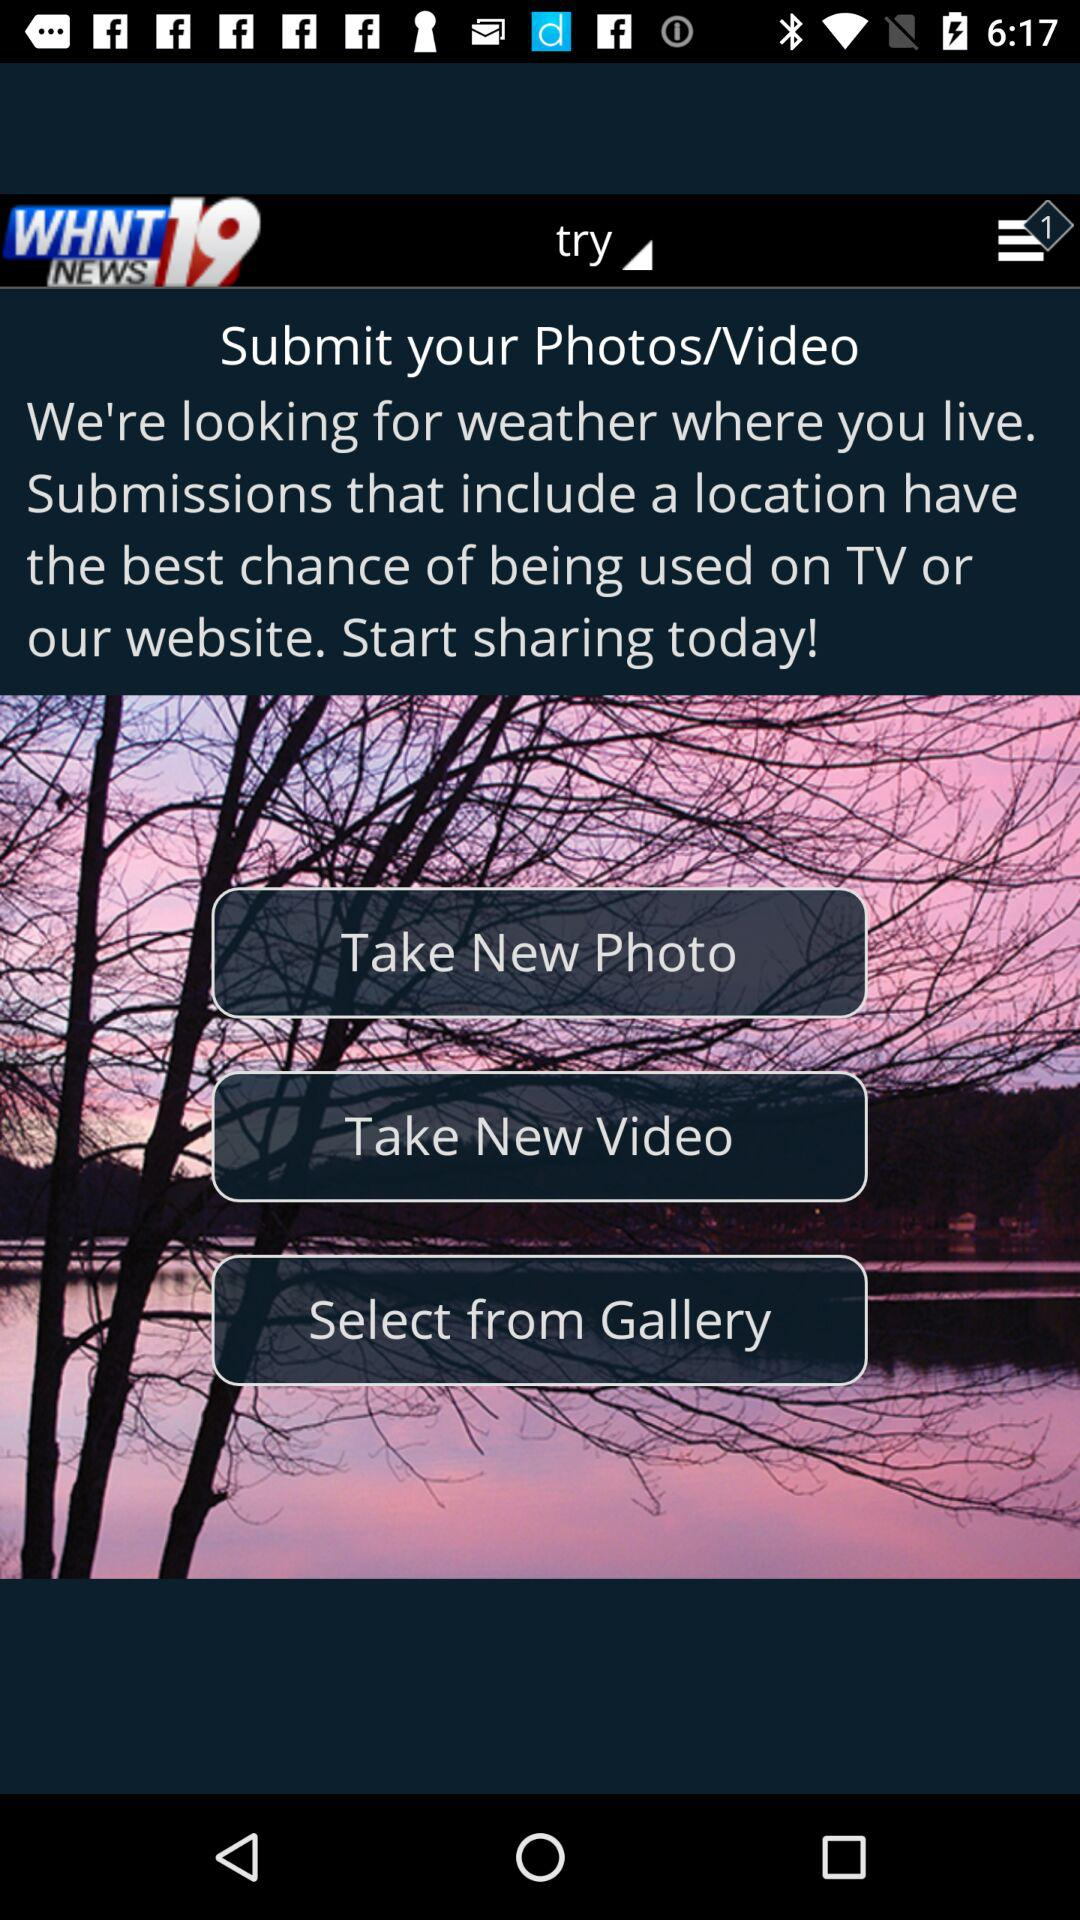What is the name of the application? The name of the application is "WHNT 19 News". 